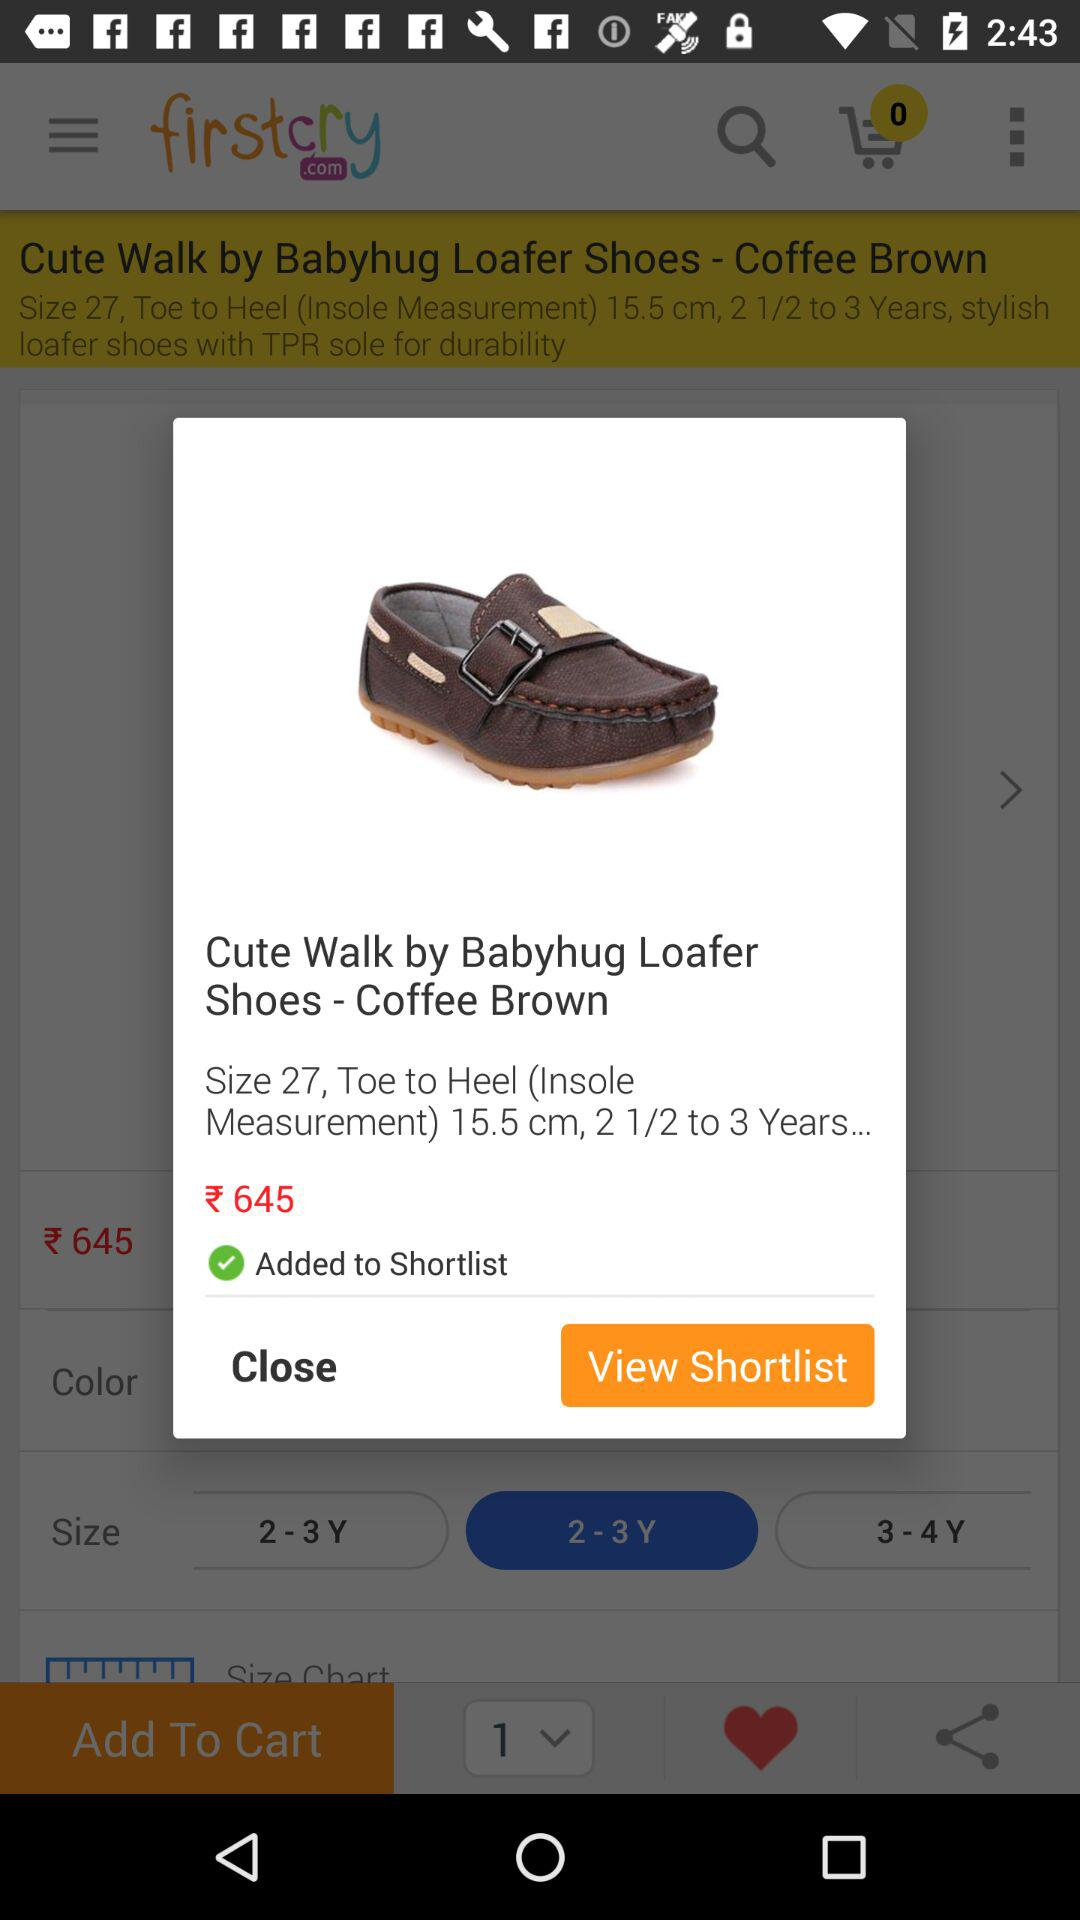How many items are in your shopping cart? There are 0 items in your shopping cart. 